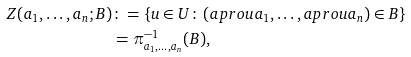Convert formula to latex. <formula><loc_0><loc_0><loc_500><loc_500>Z ( a _ { 1 } , \dots , a _ { n } ; B ) & \colon = \{ u \in U \colon \, ( a p r o { u } { a _ { 1 } } , \dots , a p r o { u } { a _ { n } } ) \in B \} \\ & = \pi ^ { - 1 } _ { a _ { 1 } , \dots , a _ { n } } ( B ) ,</formula> 